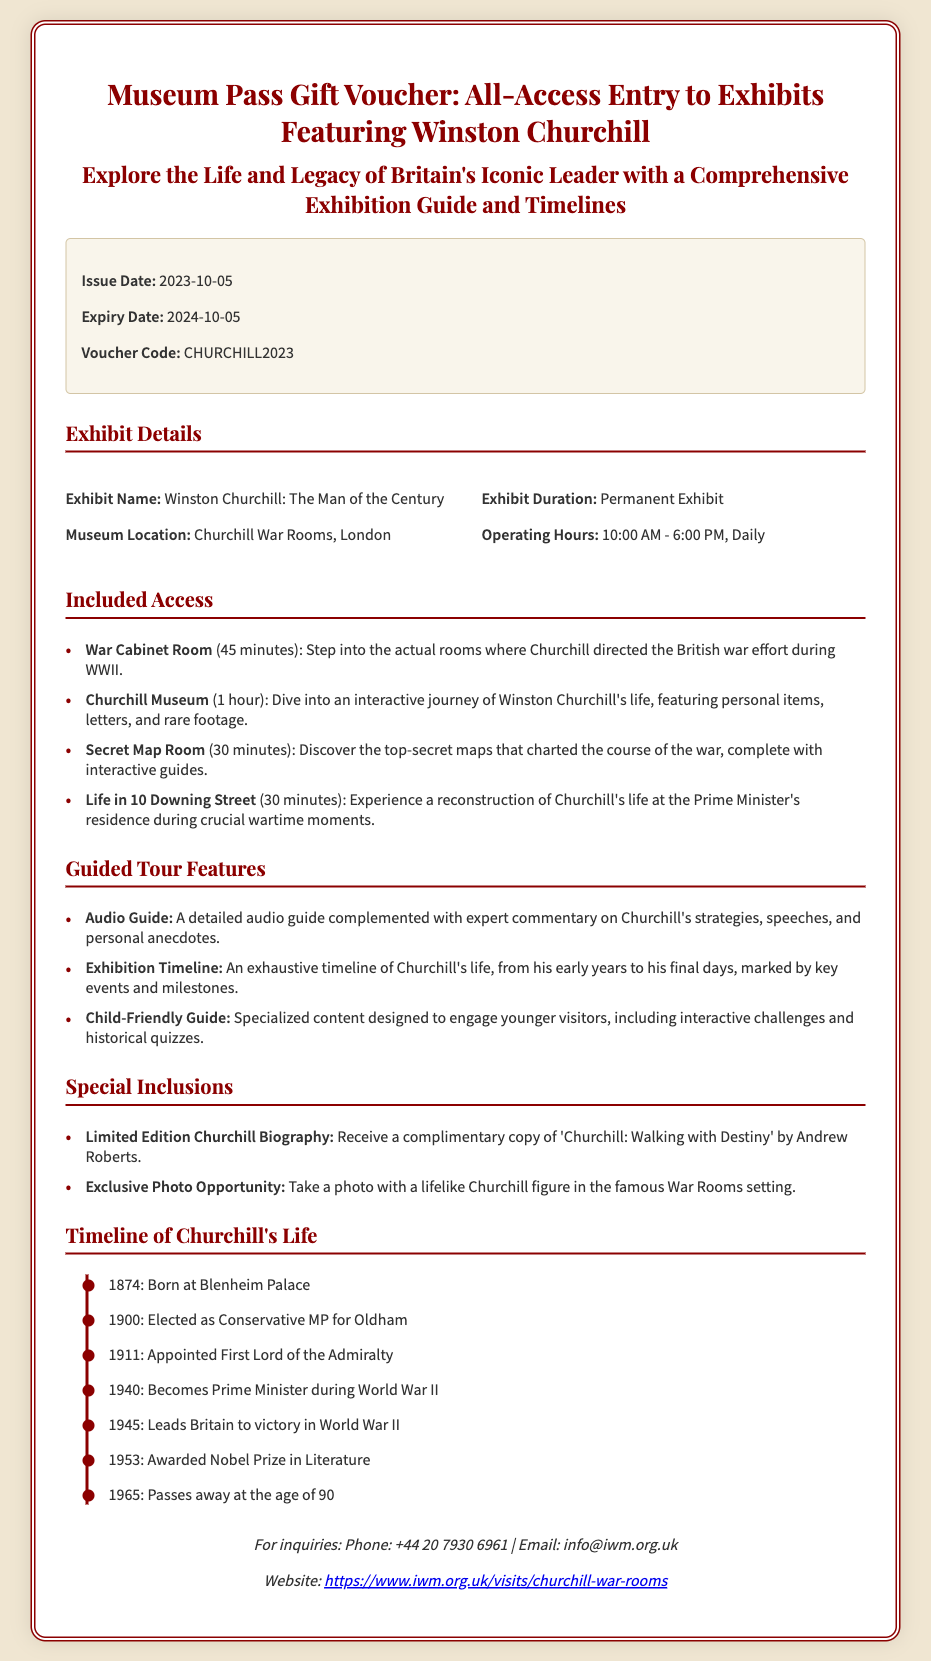What is the issue date of the voucher? The issue date is specified as the date when the voucher was released, which is listed in the voucher details.
Answer: 2023-10-05 What is the expiry date of the voucher? The expiry date indicates when the voucher will no longer be valid, found in the voucher details section.
Answer: 2024-10-05 Where is the exhibit located? The museum location of the exhibit is detailed under the exhibit details section, indicating where visitors can find it.
Answer: Churchill War Rooms, London What is the duration of the Churchill Museum exhibit? This indicates how long the exhibit will be available to visitors, as mentioned in the document.
Answer: Permanent Exhibit Which complimentary item is included with the voucher? The specific complimentary item provided as part of the special inclusions section details what visitors will receive.
Answer: Limited Edition Churchill Biography How long is the audio guide feature? This question examines how long a specific feature is expected to last during the visit, based on the guided tour information.
Answer: Not specified What historical event marks the year 1940 in Churchill's life? This requires connecting information about Churchill's timeline with significant historical events he was involved in.
Answer: Becomes Prime Minister during World War II What is the voucher code? The code is a unique identifier for the voucher which is important for redemption, found in the voucher details section.
Answer: CHURCHILL2023 Which key event happened in 1953? This question connects to the timeline provided in the document, asking for a significant date related to Churchill's accomplishments.
Answer: Awarded Nobel Prize in Literature 